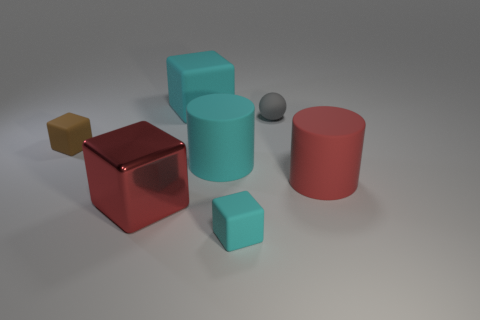Add 1 gray matte cylinders. How many objects exist? 8 Subtract all rubber cubes. How many cubes are left? 1 Subtract all cyan blocks. How many blocks are left? 2 Subtract all blocks. How many objects are left? 3 Subtract all red blocks. Subtract all brown spheres. How many blocks are left? 3 Subtract all blue balls. How many blue cylinders are left? 0 Subtract all big cyan rubber cylinders. Subtract all cyan matte objects. How many objects are left? 3 Add 6 big cyan matte cylinders. How many big cyan matte cylinders are left? 7 Add 4 small brown things. How many small brown things exist? 5 Subtract 0 cyan balls. How many objects are left? 7 